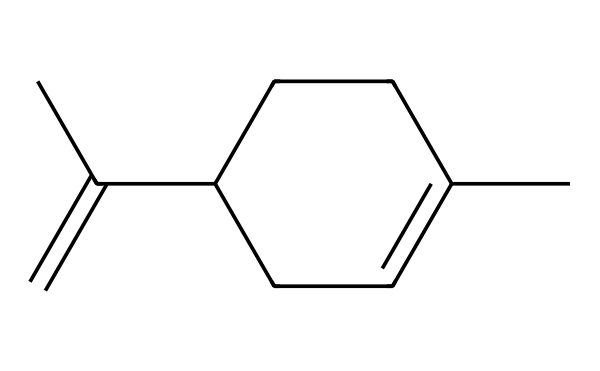What is the molecular formula of limonene? By analyzing the structure from the SMILES representation, we count the number of carbon (C) and hydrogen (H) atoms. There are 10 carbon atoms and 16 hydrogen atoms, yielding the molecular formula C10H16.
Answer: C10H16 How many rings are present in limonene's structure? The structure presented does not contain any rings; therefore, the count is zero. Since there are no cyclic components, it is a non-cyclic compound.
Answer: 0 What type of functional group is present in limonene? The structure reveals that while limonene resembles a hydrocarbon, it lacks the carbonyl group characteristic of ketones; thus, it is classified as a terpene rather than a ketone.
Answer: terpene What is the primary characteristic of limonene's scent? Limonene is known for its strong citrus odor, often associated with oranges and lemons. This is a defining feature of its use in cleaning products and fragrances.
Answer: citrus How many double bonds are in the limonene structure? The analysis of the structure indicates that there is one double bond present in the carbon chain, specifically between the two carbons of the alkene segment.
Answer: 1 What is the significance of the double bond in limonene? The double bond contributes to the reactivity and the unique aromatic properties of limonene, which are crucial for its effectiveness in scent production in cleaning products.
Answer: reactivity Is limonene a saturated or unsaturated compound? Since limonene contains a double bond and does not have the maximum number of hydrogen atoms possible for its carbon skeleton, it is classified as an unsaturated compound.
Answer: unsaturated 